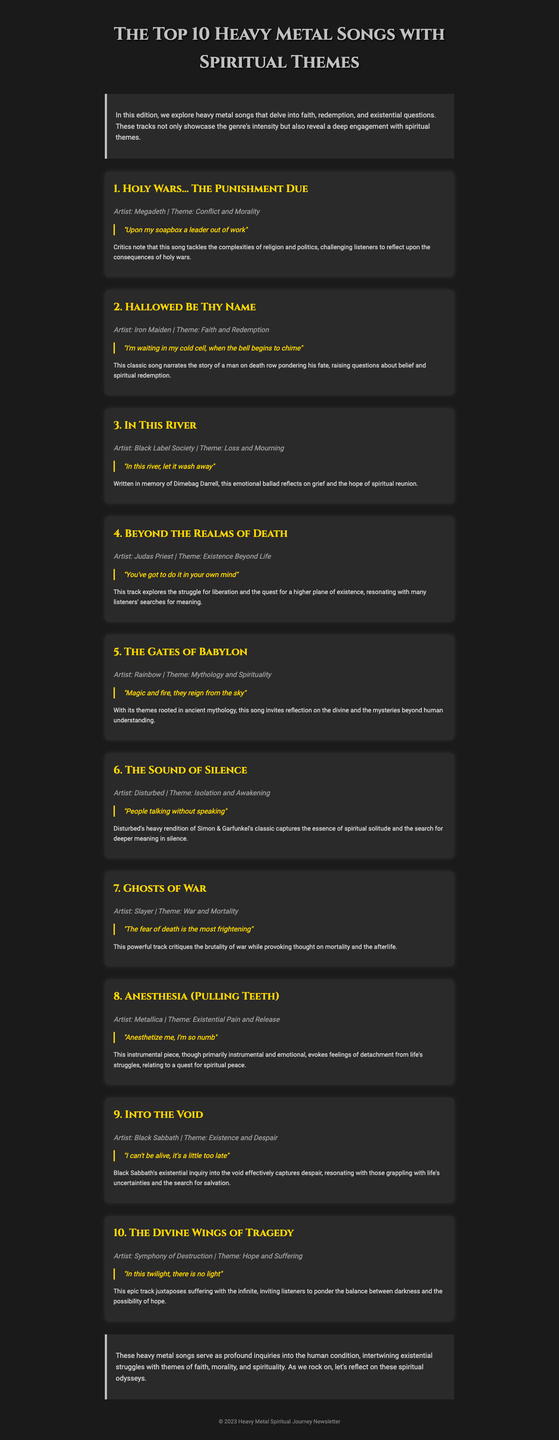what is the title of the newsletter? The title is prominently displayed at the top of the document as the main header.
Answer: The Top 10 Heavy Metal Songs with Spiritual Themes how many songs are listed in the document? The document includes a list of songs, each specified in its own section.
Answer: 10 who is the artist of "Hallowed Be Thy Name"? The artist's name is mentioned alongside the song title in the song's section.
Answer: Iron Maiden what theme does "The Sound of Silence" address? The theme is provided in a descriptive line following the song's title and artist.
Answer: Isolation and Awakening which song references mythology and spirituality? This question looks for the song that has both elements in its commentary.
Answer: The Gates of Babylon what is the concluding thought about the songs in the document? The conclusion summarizes the overarching message of the songs and their themes.
Answer: Spiritual inquiries into the human condition who is remembered in the song "In This River"? The commentary provides a specific individual tied to the song's emotional context.
Answer: Dimebag Darrell what common topic is discussed in multiple songs? This question seeks to find recurring themes mentioned in the commentary.
Answer: Spiritual themes which artist performed "Ghosts of War"? The artist is noted in each song's section, alongside the title.
Answer: Slayer 